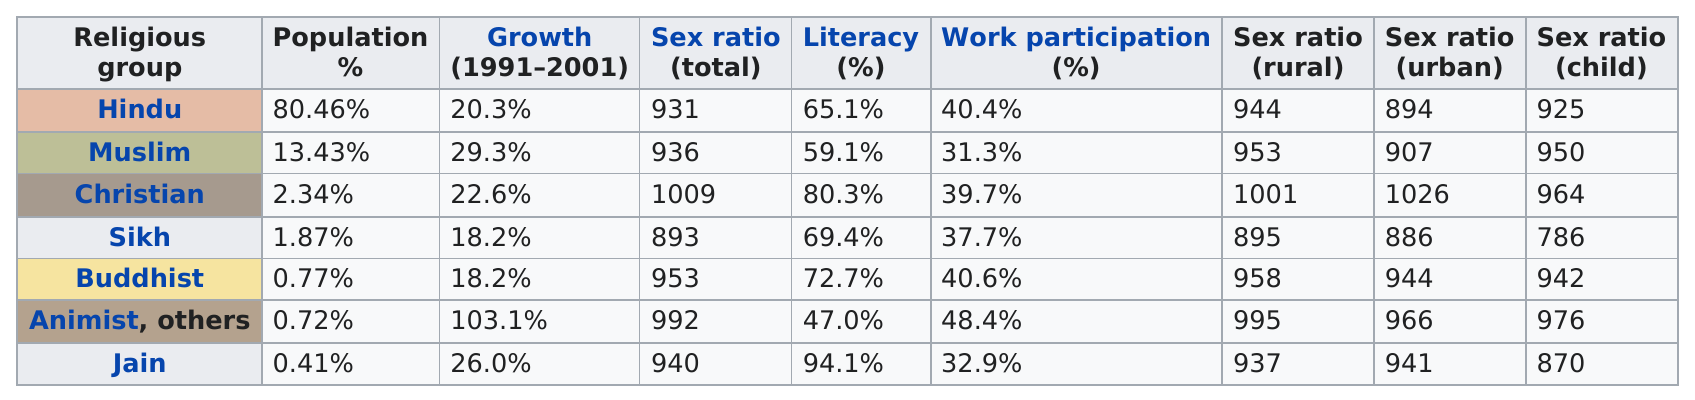Specify some key components in this picture. Out of these religious groups, it is noted that only 5 have literacy rates above 60%. According to available information, only three religious groups have literacy rates of at least 70%. During the period of 1991-2001, the two religious groups that showed the least amount of growth were the Sikh and Buddhist communities. Jainism is the only religious group that has a literacy rate above 90%. Jainism is a religion that has a relatively low percentage of followers in India, compared to other major religions in the country. 